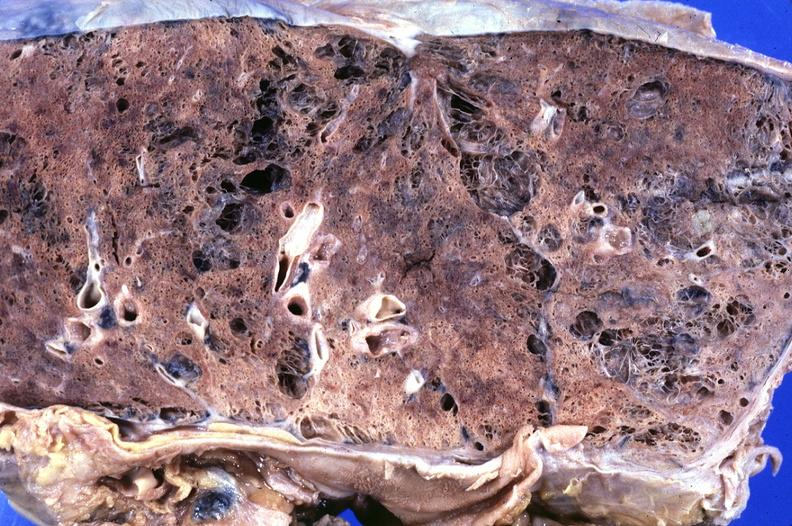s nodular tumor present?
Answer the question using a single word or phrase. No 